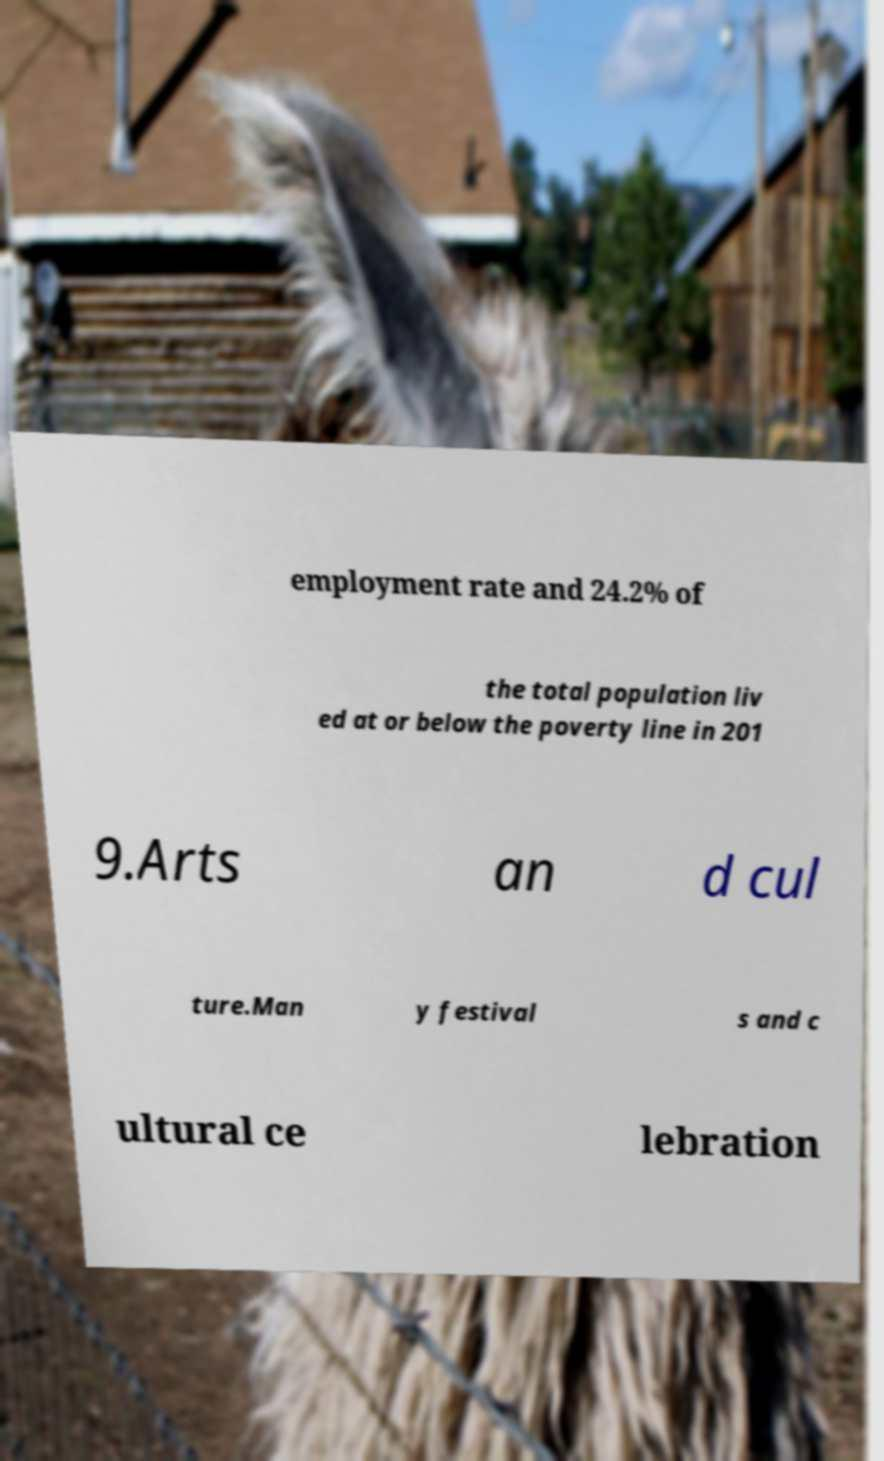What messages or text are displayed in this image? I need them in a readable, typed format. employment rate and 24.2% of the total population liv ed at or below the poverty line in 201 9.Arts an d cul ture.Man y festival s and c ultural ce lebration 